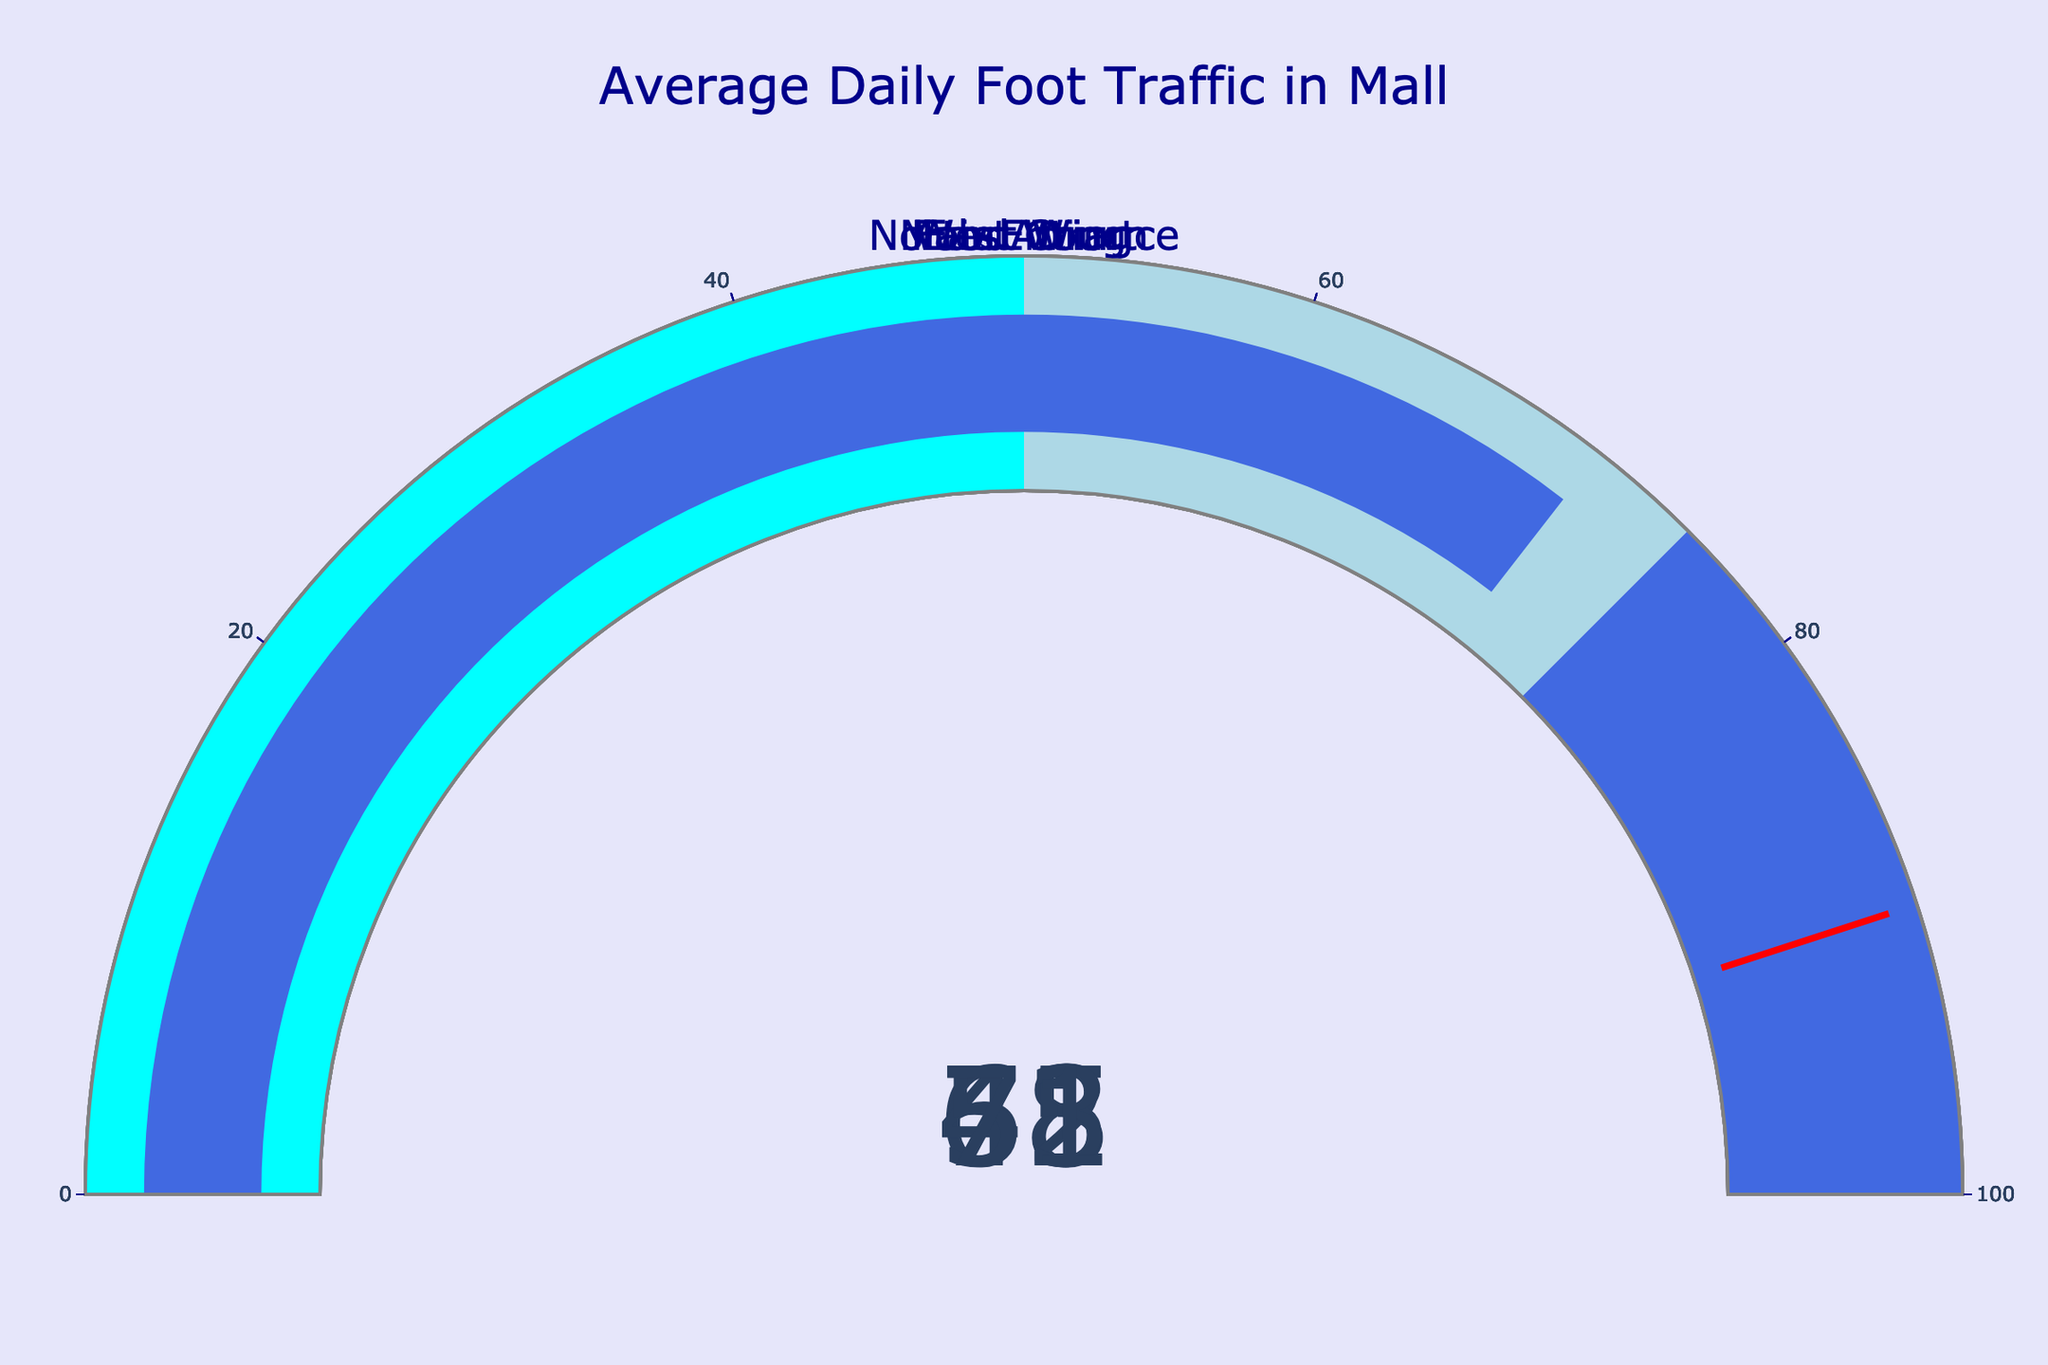Which location has the highest average daily foot traffic? The Food Court gauge shows the highest percentage value among all locations on the figure at 78%.
Answer: Food Court What's the average of the displayed percentages for all locations? Sum up the percentages from all locations (78 + 62 + 45 + 53 + 71) and divide by the number of locations (5). The average is (78 + 62 + 45 + 53 + 71) / 5 = 309 / 5 = 61.8.
Answer: 61.8 Which location's percentage is closest to 50%? Look at all the percentages and see which is closest to 50%. The East Wing at 53% is the closest.
Answer: East Wing Compare the percentages of the Main Atrium and North Entrance. Which one is higher? The Main Atrium shows 62%, while the North Entrance shows 71%. Therefore, the North Entrance is higher.
Answer: North Entrance What is the total foot traffic in percentage across all locations combined? Add up the percentages from all locations (78 + 62 + 45 + 53 + 71). The total is 78 + 62 + 45 + 53 + 71 = 309.
Answer: 309 Which locations have less than 60% of maximum capacity foot traffic? The West Wing (45%) and the East Wing (53%) both have percentages less than 60%.
Answer: West Wing, East Wing Is the average daily foot traffic in the North Entrance more than 20% higher than in the West Wing? First, calculate 20% of the West Wing's value, which is 20% of 45 = 0.2 * 45 = 9. Adding this to 45 gives 45 + 9 = 54. Since the North Entrance's 71% is indeed more than 54%, the answer is yes.
Answer: Yes Which location has a percentage that falls into the light blue range on the gauge? The light blue range corresponds to percentages from 50 to 75. Locations that fall into this range are Main Atrium (62%), East Wing (53%), and North Entrance (71%).
Answer: Main Atrium, East Wing, North Entrance 